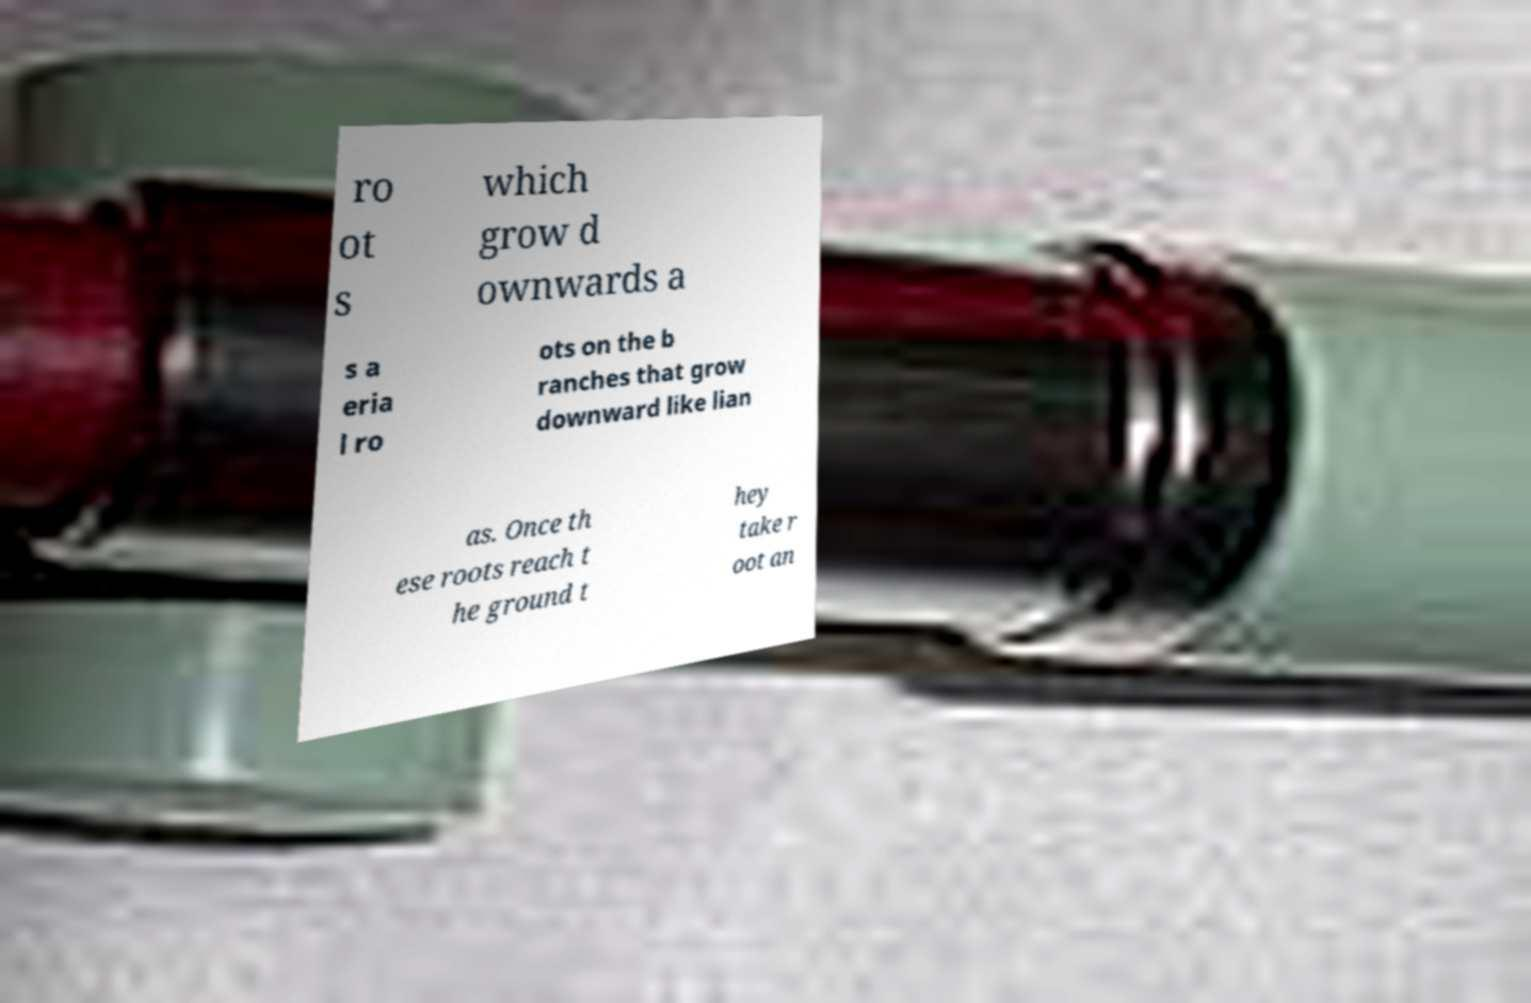There's text embedded in this image that I need extracted. Can you transcribe it verbatim? ro ot s which grow d ownwards a s a eria l ro ots on the b ranches that grow downward like lian as. Once th ese roots reach t he ground t hey take r oot an 